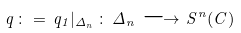Convert formula to latex. <formula><loc_0><loc_0><loc_500><loc_500>q \, \colon = \, q _ { 1 } | _ { \Delta _ { n } } \, \colon \, \Delta _ { n } \, \longrightarrow \, S ^ { n } ( C )</formula> 